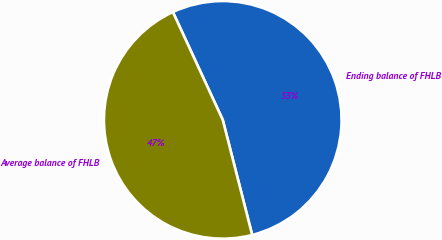<chart> <loc_0><loc_0><loc_500><loc_500><pie_chart><fcel>Ending balance of FHLB<fcel>Average balance of FHLB<nl><fcel>52.91%<fcel>47.09%<nl></chart> 